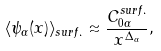<formula> <loc_0><loc_0><loc_500><loc_500>\langle \psi _ { \alpha } ( x ) \rangle _ { s u r f . } \approx \frac { C ^ { s u r f . } _ { 0 \alpha } } { x ^ { \Delta _ { \alpha } } } , \\</formula> 